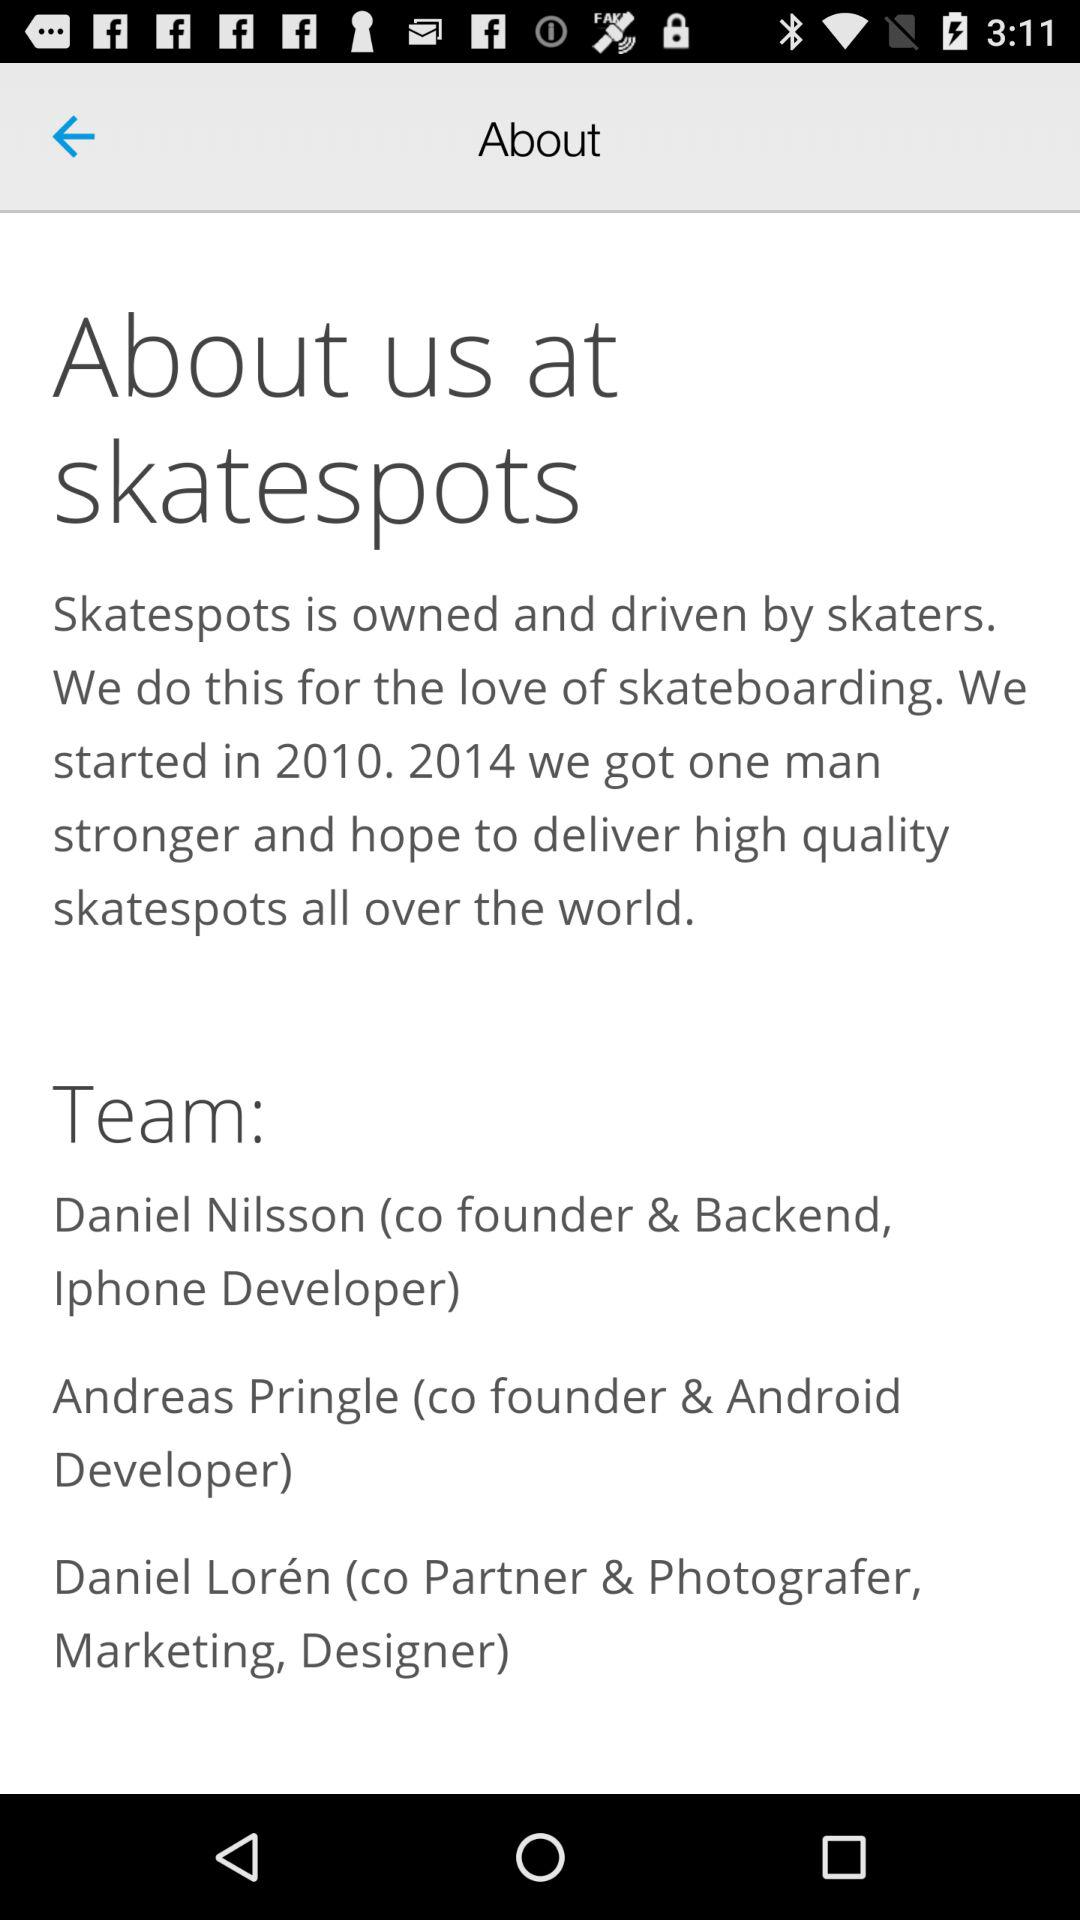How many people are on the team?
Answer the question using a single word or phrase. 3 